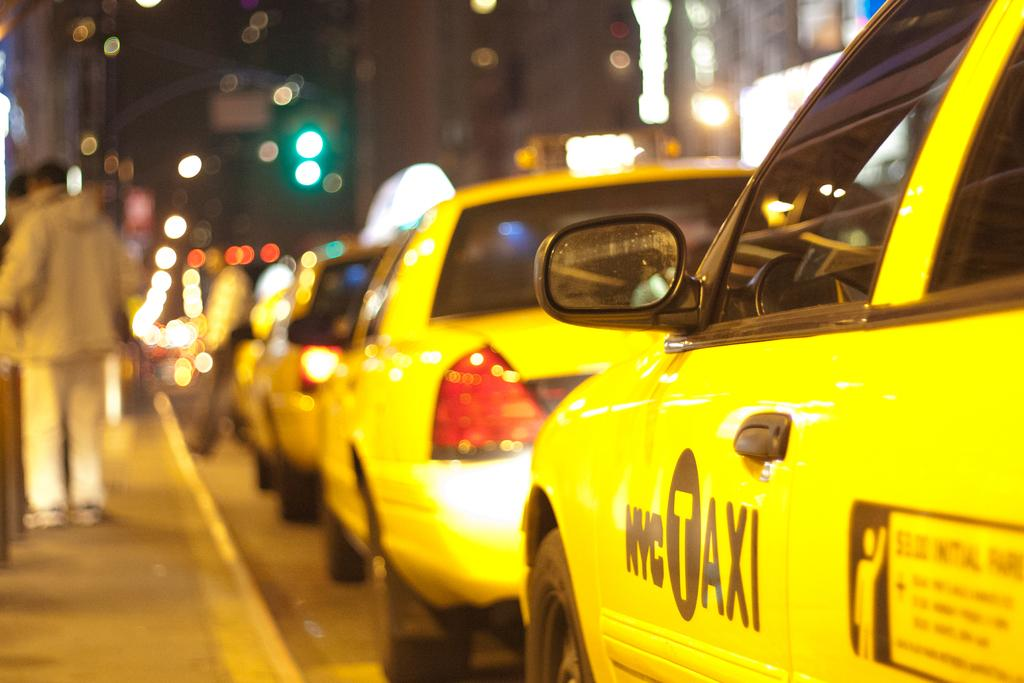Provide a one-sentence caption for the provided image. A row of yellow NYC Taxis lined up at the curb. 